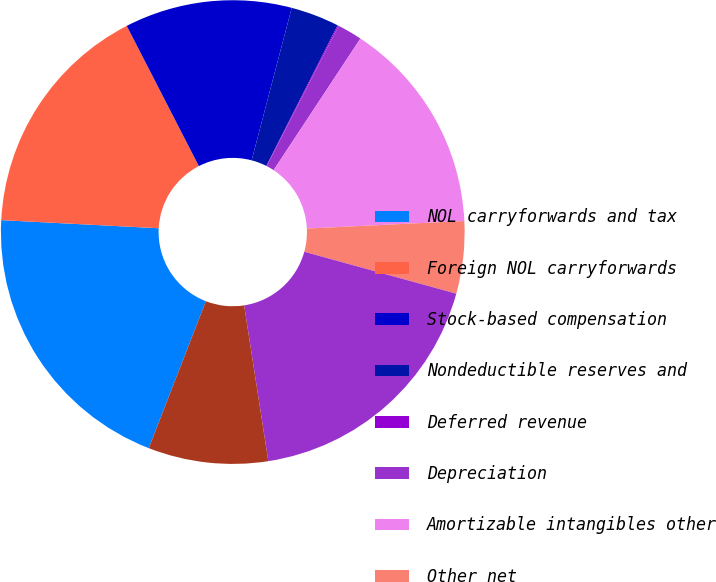Convert chart. <chart><loc_0><loc_0><loc_500><loc_500><pie_chart><fcel>NOL carryforwards and tax<fcel>Foreign NOL carryforwards<fcel>Stock-based compensation<fcel>Nondeductible reserves and<fcel>Deferred revenue<fcel>Depreciation<fcel>Amortizable intangibles other<fcel>Other net<fcel>Capitalized research and<fcel>Identified intangibles<nl><fcel>19.92%<fcel>16.62%<fcel>11.65%<fcel>3.38%<fcel>0.08%<fcel>1.73%<fcel>14.96%<fcel>5.04%<fcel>18.27%<fcel>8.35%<nl></chart> 